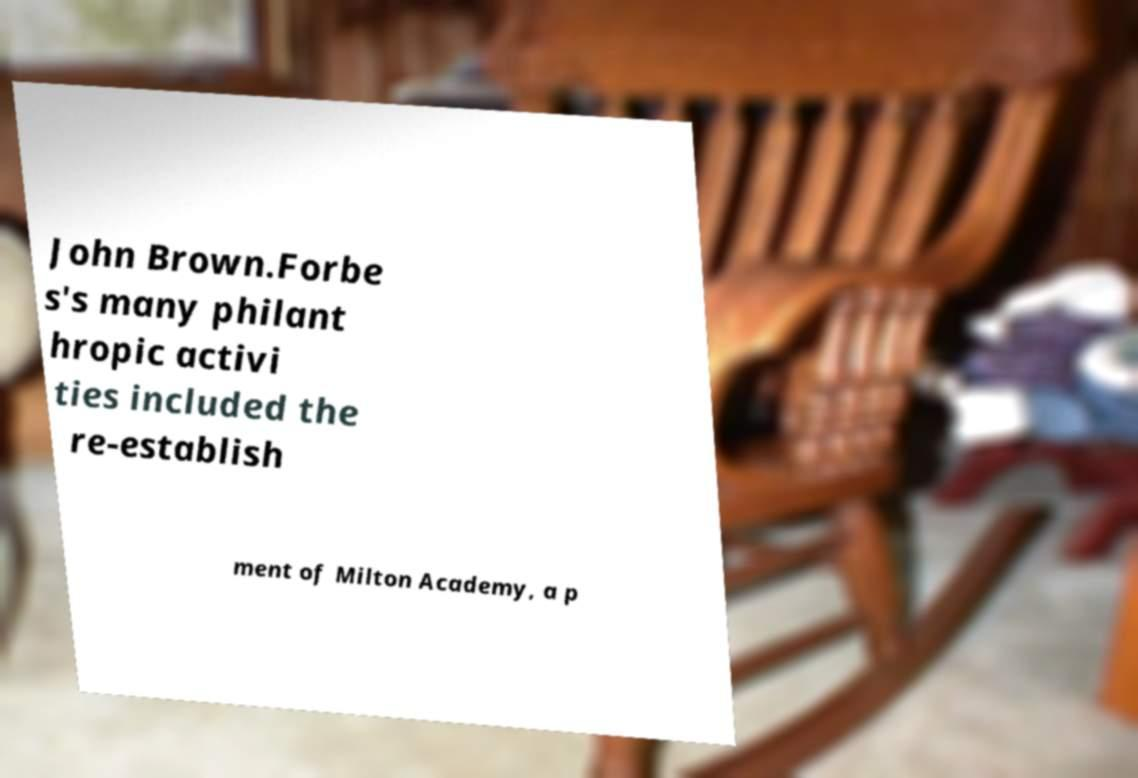What messages or text are displayed in this image? I need them in a readable, typed format. John Brown.Forbe s's many philant hropic activi ties included the re-establish ment of Milton Academy, a p 